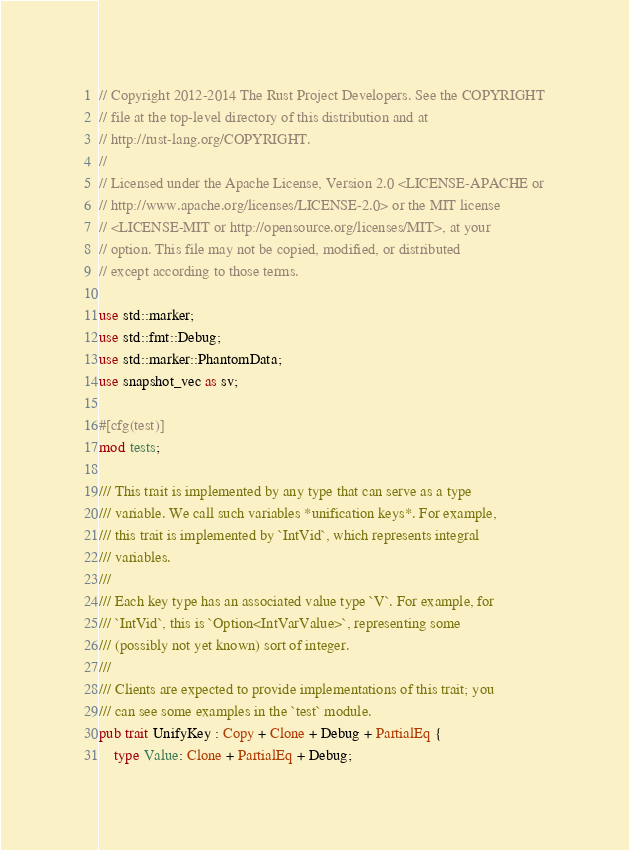Convert code to text. <code><loc_0><loc_0><loc_500><loc_500><_Rust_>// Copyright 2012-2014 The Rust Project Developers. See the COPYRIGHT
// file at the top-level directory of this distribution and at
// http://rust-lang.org/COPYRIGHT.
//
// Licensed under the Apache License, Version 2.0 <LICENSE-APACHE or
// http://www.apache.org/licenses/LICENSE-2.0> or the MIT license
// <LICENSE-MIT or http://opensource.org/licenses/MIT>, at your
// option. This file may not be copied, modified, or distributed
// except according to those terms.

use std::marker;
use std::fmt::Debug;
use std::marker::PhantomData;
use snapshot_vec as sv;

#[cfg(test)]
mod tests;

/// This trait is implemented by any type that can serve as a type
/// variable. We call such variables *unification keys*. For example,
/// this trait is implemented by `IntVid`, which represents integral
/// variables.
///
/// Each key type has an associated value type `V`. For example, for
/// `IntVid`, this is `Option<IntVarValue>`, representing some
/// (possibly not yet known) sort of integer.
///
/// Clients are expected to provide implementations of this trait; you
/// can see some examples in the `test` module.
pub trait UnifyKey : Copy + Clone + Debug + PartialEq {
    type Value: Clone + PartialEq + Debug;
</code> 